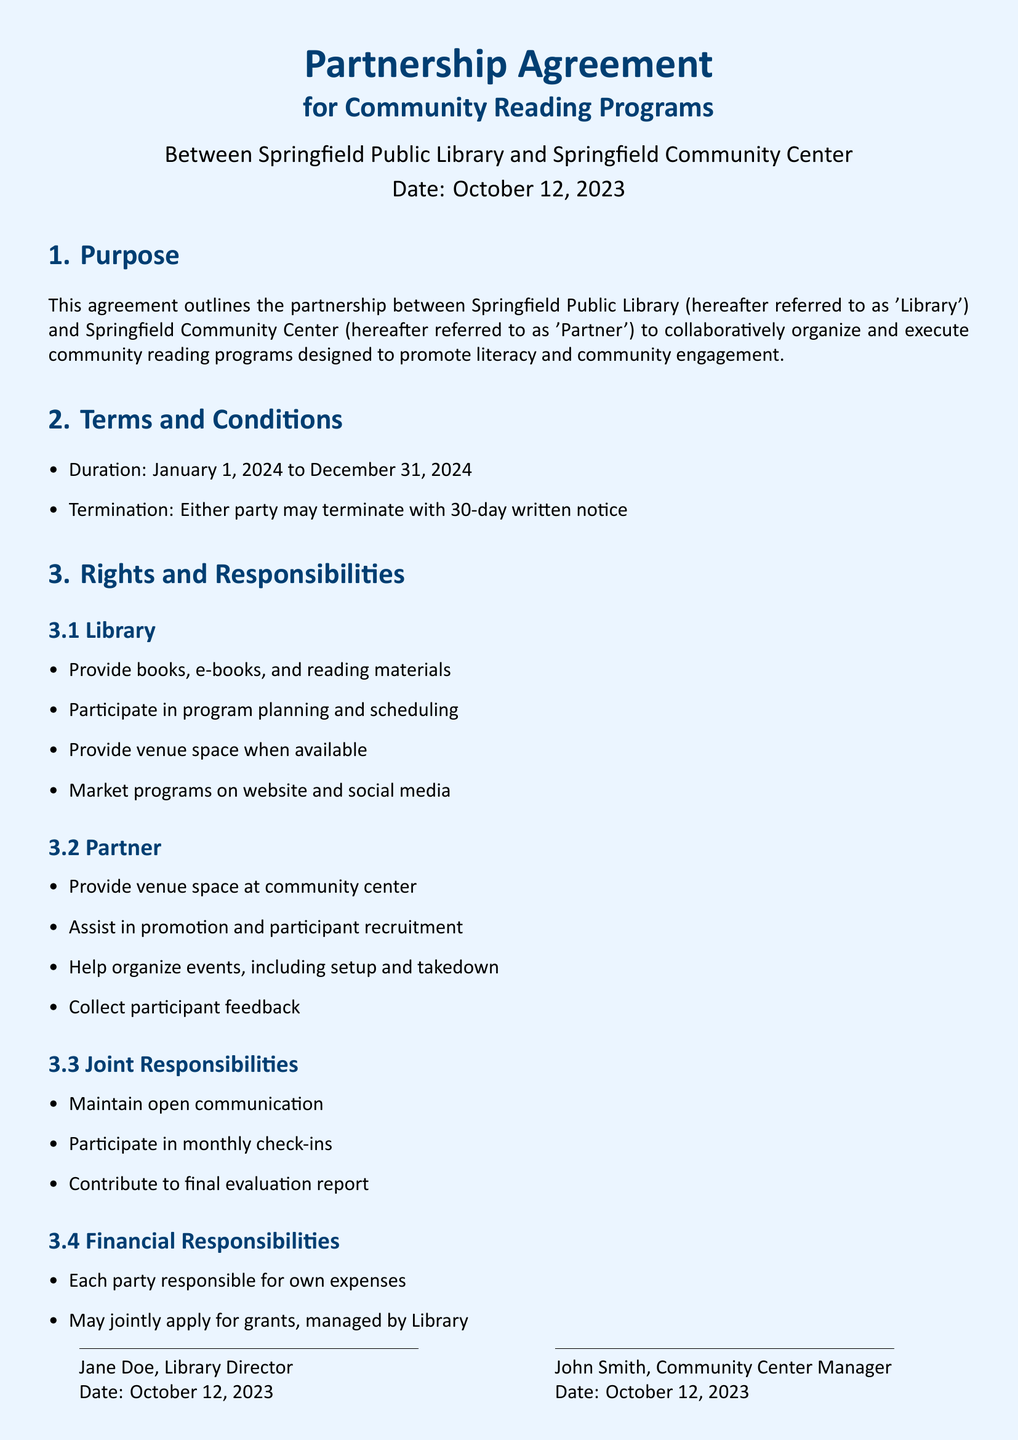What is the duration of the partnership? The duration is specified in the terms and conditions of the agreement, which is from January 1, 2024 to December 31, 2024.
Answer: January 1, 2024 to December 31, 2024 Who is the Library Director? The document includes signatures and names of the individuals, which state that Jane Doe is the Library Director.
Answer: Jane Doe What is one responsibility of the Library? The responsibilities of the Library include providing books, e-books, and reading materials, as stated in section 3.1.
Answer: Provide books, e-books, and reading materials How many individuals signed the agreement? There are two signature sections in the document, indicating two individuals signed the agreement.
Answer: Two What is a joint responsibility listed in the agreement? The joint responsibilities are specified in section 3.3, which states that the parties must maintain open communication among other tasks.
Answer: Maintain open communication What is the termination notice period? The termination conditions are described in section 2, which specifies a 30-day written notice.
Answer: 30-day written notice What organization is the Partner in this agreement? The document clearly states that the Partner is the Springfield Community Center.
Answer: Springfield Community Center What is the date of the agreement? The date is provided at the beginning of the document and is October 12, 2023.
Answer: October 12, 2023 